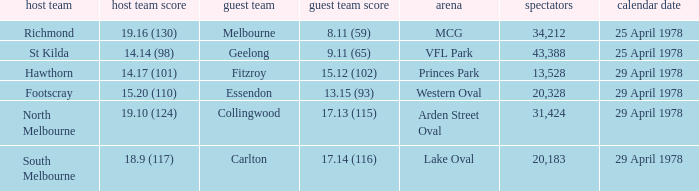In what venue was the hosted away team Essendon? Western Oval. 